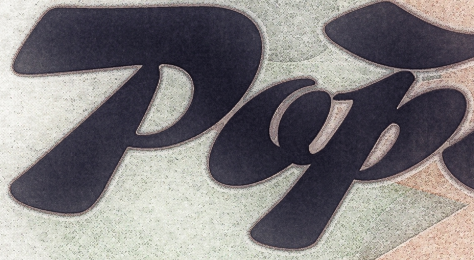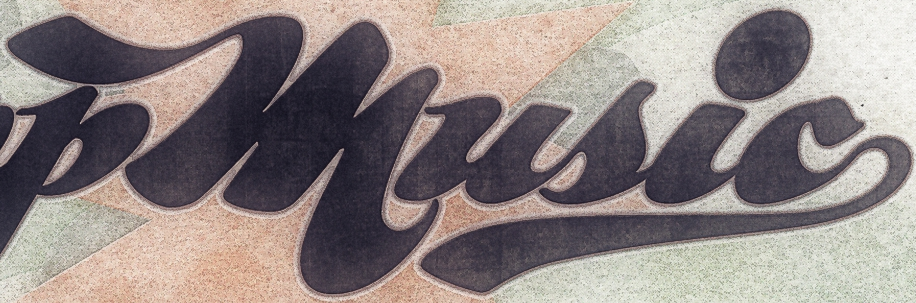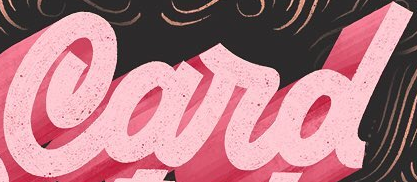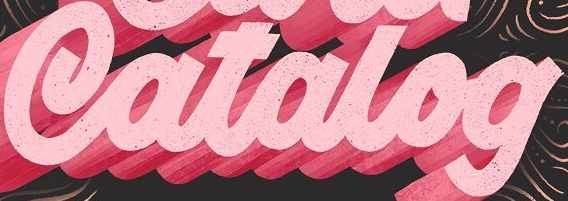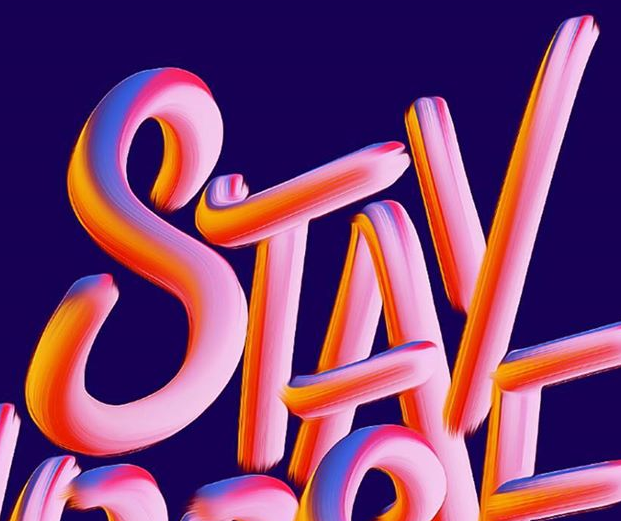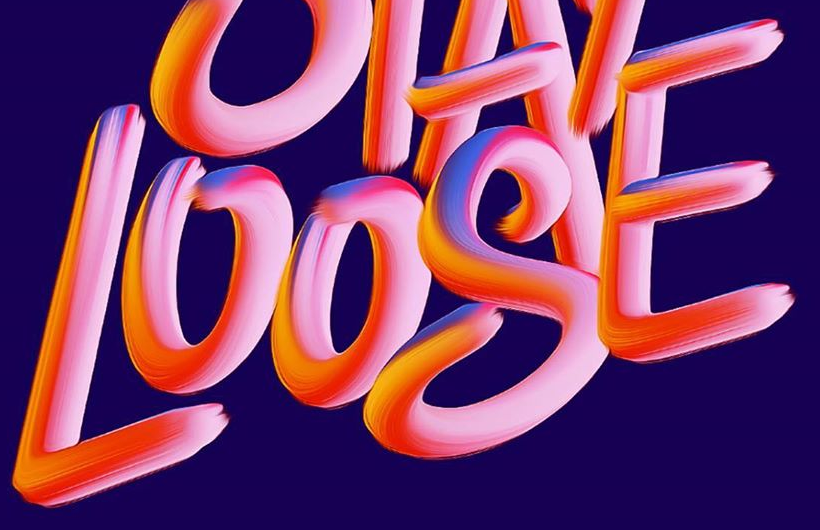Read the text content from these images in order, separated by a semicolon. Pop; music; Card; Catalog; STAY; LOOSE 